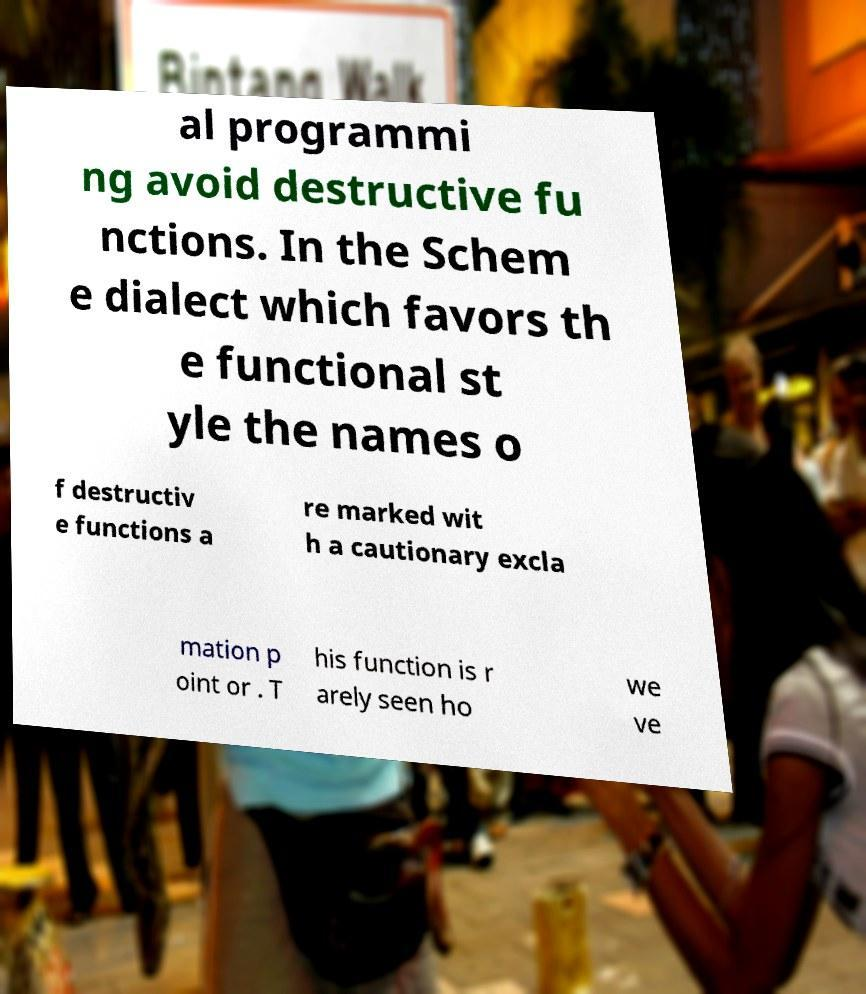For documentation purposes, I need the text within this image transcribed. Could you provide that? al programmi ng avoid destructive fu nctions. In the Schem e dialect which favors th e functional st yle the names o f destructiv e functions a re marked wit h a cautionary excla mation p oint or . T his function is r arely seen ho we ve 